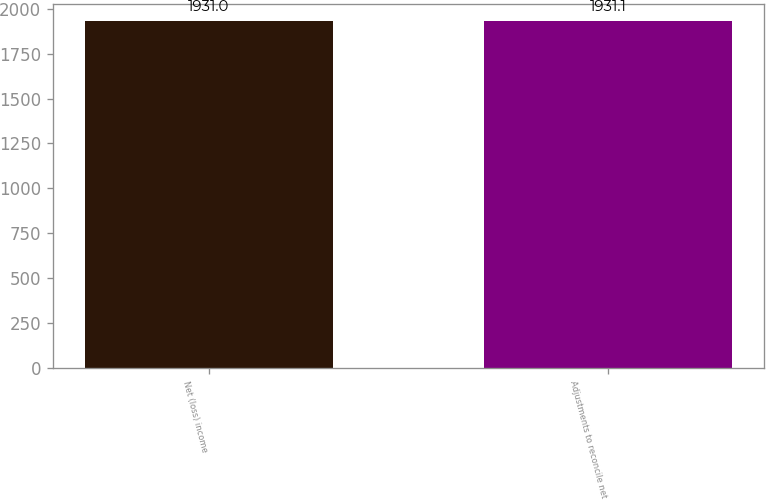Convert chart to OTSL. <chart><loc_0><loc_0><loc_500><loc_500><bar_chart><fcel>Net (loss) income<fcel>Adjustments to reconcile net<nl><fcel>1931<fcel>1931.1<nl></chart> 